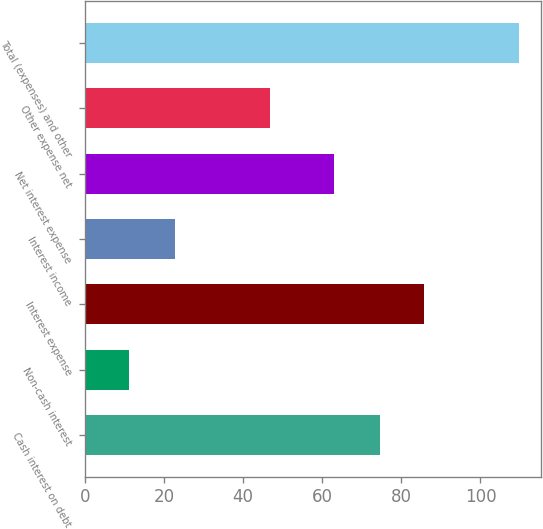Convert chart. <chart><loc_0><loc_0><loc_500><loc_500><bar_chart><fcel>Cash interest on debt<fcel>Non-cash interest<fcel>Interest expense<fcel>Interest income<fcel>Net interest expense<fcel>Other expense net<fcel>Total (expenses) and other<nl><fcel>74.6<fcel>11.2<fcel>85.8<fcel>22.8<fcel>63<fcel>46.7<fcel>109.7<nl></chart> 